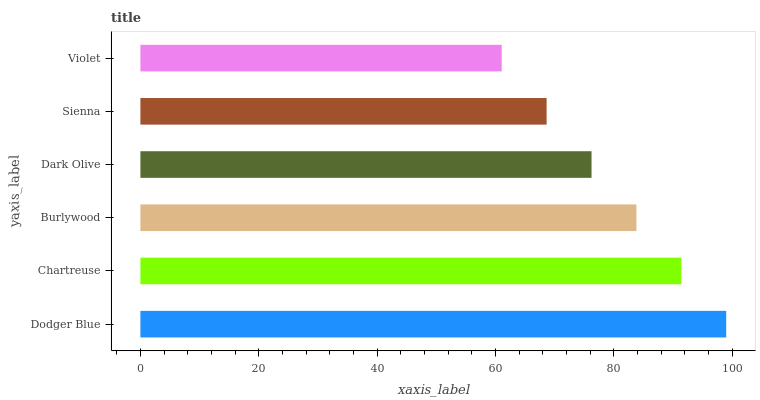Is Violet the minimum?
Answer yes or no. Yes. Is Dodger Blue the maximum?
Answer yes or no. Yes. Is Chartreuse the minimum?
Answer yes or no. No. Is Chartreuse the maximum?
Answer yes or no. No. Is Dodger Blue greater than Chartreuse?
Answer yes or no. Yes. Is Chartreuse less than Dodger Blue?
Answer yes or no. Yes. Is Chartreuse greater than Dodger Blue?
Answer yes or no. No. Is Dodger Blue less than Chartreuse?
Answer yes or no. No. Is Burlywood the high median?
Answer yes or no. Yes. Is Dark Olive the low median?
Answer yes or no. Yes. Is Dark Olive the high median?
Answer yes or no. No. Is Dodger Blue the low median?
Answer yes or no. No. 